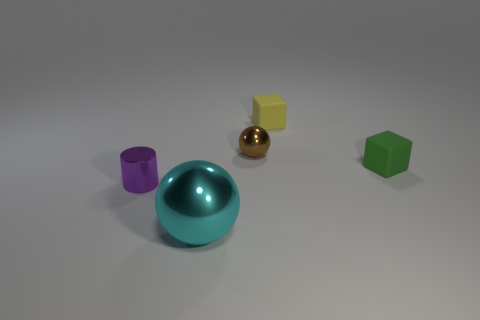How many other things are there of the same size as the cyan sphere?
Keep it short and to the point. 0. How many purple metallic things are there?
Your response must be concise. 1. Is the brown metallic ball the same size as the yellow matte block?
Ensure brevity in your answer.  Yes. How many other things are the same shape as the purple thing?
Provide a succinct answer. 0. What material is the block that is behind the metallic ball that is behind the cyan object?
Ensure brevity in your answer.  Rubber. Are there any big metal balls behind the yellow matte thing?
Your answer should be very brief. No. There is a brown object; is its size the same as the matte cube that is in front of the small yellow rubber cube?
Make the answer very short. Yes. What size is the green matte object that is the same shape as the tiny yellow object?
Provide a short and direct response. Small. Is there anything else that has the same material as the small green block?
Your answer should be very brief. Yes. There is a metal sphere that is right of the big cyan metallic sphere; does it have the same size as the yellow rubber object behind the cyan ball?
Your answer should be compact. Yes. 